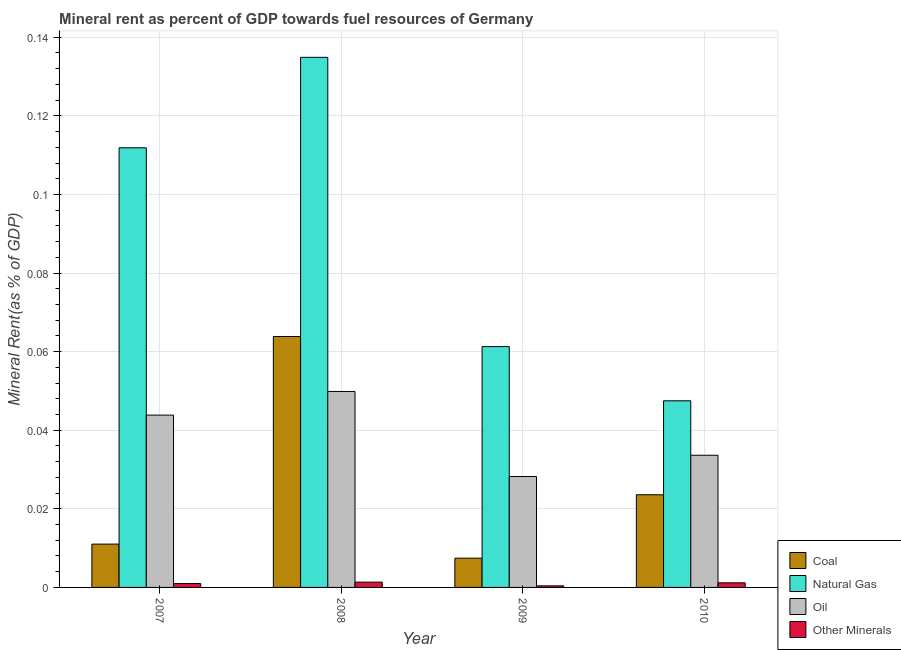How many different coloured bars are there?
Ensure brevity in your answer.  4. How many groups of bars are there?
Your answer should be compact. 4. Are the number of bars on each tick of the X-axis equal?
Make the answer very short. Yes. In how many cases, is the number of bars for a given year not equal to the number of legend labels?
Provide a succinct answer. 0. What is the natural gas rent in 2009?
Offer a very short reply. 0.06. Across all years, what is the maximum coal rent?
Your answer should be compact. 0.06. Across all years, what is the minimum  rent of other minerals?
Offer a terse response. 0. What is the total coal rent in the graph?
Provide a succinct answer. 0.11. What is the difference between the natural gas rent in 2008 and that in 2010?
Offer a very short reply. 0.09. What is the difference between the coal rent in 2010 and the  rent of other minerals in 2007?
Ensure brevity in your answer.  0.01. What is the average natural gas rent per year?
Provide a succinct answer. 0.09. In the year 2010, what is the difference between the  rent of other minerals and coal rent?
Your answer should be very brief. 0. In how many years, is the natural gas rent greater than 0.132 %?
Provide a succinct answer. 1. What is the ratio of the  rent of other minerals in 2008 to that in 2009?
Give a very brief answer. 3.35. Is the natural gas rent in 2007 less than that in 2010?
Provide a succinct answer. No. What is the difference between the highest and the second highest natural gas rent?
Offer a terse response. 0.02. What is the difference between the highest and the lowest oil rent?
Your answer should be compact. 0.02. What does the 3rd bar from the left in 2009 represents?
Give a very brief answer. Oil. What does the 4th bar from the right in 2009 represents?
Provide a short and direct response. Coal. Are the values on the major ticks of Y-axis written in scientific E-notation?
Ensure brevity in your answer.  No. Does the graph contain any zero values?
Give a very brief answer. No. Where does the legend appear in the graph?
Provide a succinct answer. Bottom right. What is the title of the graph?
Your answer should be very brief. Mineral rent as percent of GDP towards fuel resources of Germany. Does "Manufacturing" appear as one of the legend labels in the graph?
Give a very brief answer. No. What is the label or title of the Y-axis?
Keep it short and to the point. Mineral Rent(as % of GDP). What is the Mineral Rent(as % of GDP) in Coal in 2007?
Provide a short and direct response. 0.01. What is the Mineral Rent(as % of GDP) of Natural Gas in 2007?
Provide a short and direct response. 0.11. What is the Mineral Rent(as % of GDP) of Oil in 2007?
Make the answer very short. 0.04. What is the Mineral Rent(as % of GDP) of Other Minerals in 2007?
Make the answer very short. 0. What is the Mineral Rent(as % of GDP) of Coal in 2008?
Offer a very short reply. 0.06. What is the Mineral Rent(as % of GDP) in Natural Gas in 2008?
Provide a succinct answer. 0.13. What is the Mineral Rent(as % of GDP) in Oil in 2008?
Provide a succinct answer. 0.05. What is the Mineral Rent(as % of GDP) of Other Minerals in 2008?
Make the answer very short. 0. What is the Mineral Rent(as % of GDP) of Coal in 2009?
Ensure brevity in your answer.  0.01. What is the Mineral Rent(as % of GDP) in Natural Gas in 2009?
Give a very brief answer. 0.06. What is the Mineral Rent(as % of GDP) of Oil in 2009?
Provide a short and direct response. 0.03. What is the Mineral Rent(as % of GDP) in Other Minerals in 2009?
Your answer should be very brief. 0. What is the Mineral Rent(as % of GDP) in Coal in 2010?
Your response must be concise. 0.02. What is the Mineral Rent(as % of GDP) of Natural Gas in 2010?
Give a very brief answer. 0.05. What is the Mineral Rent(as % of GDP) of Oil in 2010?
Your answer should be compact. 0.03. What is the Mineral Rent(as % of GDP) of Other Minerals in 2010?
Your answer should be compact. 0. Across all years, what is the maximum Mineral Rent(as % of GDP) of Coal?
Offer a very short reply. 0.06. Across all years, what is the maximum Mineral Rent(as % of GDP) in Natural Gas?
Ensure brevity in your answer.  0.13. Across all years, what is the maximum Mineral Rent(as % of GDP) in Oil?
Give a very brief answer. 0.05. Across all years, what is the maximum Mineral Rent(as % of GDP) of Other Minerals?
Offer a terse response. 0. Across all years, what is the minimum Mineral Rent(as % of GDP) in Coal?
Offer a very short reply. 0.01. Across all years, what is the minimum Mineral Rent(as % of GDP) in Natural Gas?
Provide a succinct answer. 0.05. Across all years, what is the minimum Mineral Rent(as % of GDP) of Oil?
Give a very brief answer. 0.03. Across all years, what is the minimum Mineral Rent(as % of GDP) in Other Minerals?
Give a very brief answer. 0. What is the total Mineral Rent(as % of GDP) in Coal in the graph?
Give a very brief answer. 0.11. What is the total Mineral Rent(as % of GDP) of Natural Gas in the graph?
Keep it short and to the point. 0.36. What is the total Mineral Rent(as % of GDP) of Oil in the graph?
Your answer should be compact. 0.16. What is the total Mineral Rent(as % of GDP) in Other Minerals in the graph?
Your response must be concise. 0. What is the difference between the Mineral Rent(as % of GDP) in Coal in 2007 and that in 2008?
Keep it short and to the point. -0.05. What is the difference between the Mineral Rent(as % of GDP) in Natural Gas in 2007 and that in 2008?
Ensure brevity in your answer.  -0.02. What is the difference between the Mineral Rent(as % of GDP) in Oil in 2007 and that in 2008?
Provide a short and direct response. -0.01. What is the difference between the Mineral Rent(as % of GDP) of Other Minerals in 2007 and that in 2008?
Your response must be concise. -0. What is the difference between the Mineral Rent(as % of GDP) of Coal in 2007 and that in 2009?
Keep it short and to the point. 0. What is the difference between the Mineral Rent(as % of GDP) of Natural Gas in 2007 and that in 2009?
Offer a very short reply. 0.05. What is the difference between the Mineral Rent(as % of GDP) in Oil in 2007 and that in 2009?
Your response must be concise. 0.02. What is the difference between the Mineral Rent(as % of GDP) of Other Minerals in 2007 and that in 2009?
Provide a succinct answer. 0. What is the difference between the Mineral Rent(as % of GDP) of Coal in 2007 and that in 2010?
Your answer should be very brief. -0.01. What is the difference between the Mineral Rent(as % of GDP) of Natural Gas in 2007 and that in 2010?
Ensure brevity in your answer.  0.06. What is the difference between the Mineral Rent(as % of GDP) in Oil in 2007 and that in 2010?
Provide a short and direct response. 0.01. What is the difference between the Mineral Rent(as % of GDP) in Other Minerals in 2007 and that in 2010?
Your response must be concise. -0. What is the difference between the Mineral Rent(as % of GDP) in Coal in 2008 and that in 2009?
Provide a succinct answer. 0.06. What is the difference between the Mineral Rent(as % of GDP) in Natural Gas in 2008 and that in 2009?
Provide a succinct answer. 0.07. What is the difference between the Mineral Rent(as % of GDP) in Oil in 2008 and that in 2009?
Provide a succinct answer. 0.02. What is the difference between the Mineral Rent(as % of GDP) in Other Minerals in 2008 and that in 2009?
Ensure brevity in your answer.  0. What is the difference between the Mineral Rent(as % of GDP) of Coal in 2008 and that in 2010?
Provide a short and direct response. 0.04. What is the difference between the Mineral Rent(as % of GDP) in Natural Gas in 2008 and that in 2010?
Provide a succinct answer. 0.09. What is the difference between the Mineral Rent(as % of GDP) in Oil in 2008 and that in 2010?
Offer a terse response. 0.02. What is the difference between the Mineral Rent(as % of GDP) in Other Minerals in 2008 and that in 2010?
Provide a short and direct response. 0. What is the difference between the Mineral Rent(as % of GDP) in Coal in 2009 and that in 2010?
Make the answer very short. -0.02. What is the difference between the Mineral Rent(as % of GDP) in Natural Gas in 2009 and that in 2010?
Your answer should be very brief. 0.01. What is the difference between the Mineral Rent(as % of GDP) in Oil in 2009 and that in 2010?
Make the answer very short. -0.01. What is the difference between the Mineral Rent(as % of GDP) in Other Minerals in 2009 and that in 2010?
Give a very brief answer. -0. What is the difference between the Mineral Rent(as % of GDP) in Coal in 2007 and the Mineral Rent(as % of GDP) in Natural Gas in 2008?
Your response must be concise. -0.12. What is the difference between the Mineral Rent(as % of GDP) of Coal in 2007 and the Mineral Rent(as % of GDP) of Oil in 2008?
Offer a terse response. -0.04. What is the difference between the Mineral Rent(as % of GDP) of Coal in 2007 and the Mineral Rent(as % of GDP) of Other Minerals in 2008?
Your answer should be compact. 0.01. What is the difference between the Mineral Rent(as % of GDP) of Natural Gas in 2007 and the Mineral Rent(as % of GDP) of Oil in 2008?
Offer a very short reply. 0.06. What is the difference between the Mineral Rent(as % of GDP) in Natural Gas in 2007 and the Mineral Rent(as % of GDP) in Other Minerals in 2008?
Your answer should be very brief. 0.11. What is the difference between the Mineral Rent(as % of GDP) of Oil in 2007 and the Mineral Rent(as % of GDP) of Other Minerals in 2008?
Offer a very short reply. 0.04. What is the difference between the Mineral Rent(as % of GDP) of Coal in 2007 and the Mineral Rent(as % of GDP) of Natural Gas in 2009?
Provide a succinct answer. -0.05. What is the difference between the Mineral Rent(as % of GDP) of Coal in 2007 and the Mineral Rent(as % of GDP) of Oil in 2009?
Keep it short and to the point. -0.02. What is the difference between the Mineral Rent(as % of GDP) in Coal in 2007 and the Mineral Rent(as % of GDP) in Other Minerals in 2009?
Ensure brevity in your answer.  0.01. What is the difference between the Mineral Rent(as % of GDP) in Natural Gas in 2007 and the Mineral Rent(as % of GDP) in Oil in 2009?
Offer a terse response. 0.08. What is the difference between the Mineral Rent(as % of GDP) of Natural Gas in 2007 and the Mineral Rent(as % of GDP) of Other Minerals in 2009?
Offer a very short reply. 0.11. What is the difference between the Mineral Rent(as % of GDP) of Oil in 2007 and the Mineral Rent(as % of GDP) of Other Minerals in 2009?
Provide a succinct answer. 0.04. What is the difference between the Mineral Rent(as % of GDP) in Coal in 2007 and the Mineral Rent(as % of GDP) in Natural Gas in 2010?
Offer a very short reply. -0.04. What is the difference between the Mineral Rent(as % of GDP) of Coal in 2007 and the Mineral Rent(as % of GDP) of Oil in 2010?
Give a very brief answer. -0.02. What is the difference between the Mineral Rent(as % of GDP) of Coal in 2007 and the Mineral Rent(as % of GDP) of Other Minerals in 2010?
Ensure brevity in your answer.  0.01. What is the difference between the Mineral Rent(as % of GDP) in Natural Gas in 2007 and the Mineral Rent(as % of GDP) in Oil in 2010?
Give a very brief answer. 0.08. What is the difference between the Mineral Rent(as % of GDP) of Natural Gas in 2007 and the Mineral Rent(as % of GDP) of Other Minerals in 2010?
Ensure brevity in your answer.  0.11. What is the difference between the Mineral Rent(as % of GDP) in Oil in 2007 and the Mineral Rent(as % of GDP) in Other Minerals in 2010?
Provide a succinct answer. 0.04. What is the difference between the Mineral Rent(as % of GDP) of Coal in 2008 and the Mineral Rent(as % of GDP) of Natural Gas in 2009?
Provide a succinct answer. 0. What is the difference between the Mineral Rent(as % of GDP) in Coal in 2008 and the Mineral Rent(as % of GDP) in Oil in 2009?
Offer a terse response. 0.04. What is the difference between the Mineral Rent(as % of GDP) of Coal in 2008 and the Mineral Rent(as % of GDP) of Other Minerals in 2009?
Provide a succinct answer. 0.06. What is the difference between the Mineral Rent(as % of GDP) in Natural Gas in 2008 and the Mineral Rent(as % of GDP) in Oil in 2009?
Provide a succinct answer. 0.11. What is the difference between the Mineral Rent(as % of GDP) of Natural Gas in 2008 and the Mineral Rent(as % of GDP) of Other Minerals in 2009?
Your response must be concise. 0.13. What is the difference between the Mineral Rent(as % of GDP) in Oil in 2008 and the Mineral Rent(as % of GDP) in Other Minerals in 2009?
Your response must be concise. 0.05. What is the difference between the Mineral Rent(as % of GDP) of Coal in 2008 and the Mineral Rent(as % of GDP) of Natural Gas in 2010?
Ensure brevity in your answer.  0.02. What is the difference between the Mineral Rent(as % of GDP) of Coal in 2008 and the Mineral Rent(as % of GDP) of Oil in 2010?
Provide a short and direct response. 0.03. What is the difference between the Mineral Rent(as % of GDP) of Coal in 2008 and the Mineral Rent(as % of GDP) of Other Minerals in 2010?
Make the answer very short. 0.06. What is the difference between the Mineral Rent(as % of GDP) of Natural Gas in 2008 and the Mineral Rent(as % of GDP) of Oil in 2010?
Make the answer very short. 0.1. What is the difference between the Mineral Rent(as % of GDP) in Natural Gas in 2008 and the Mineral Rent(as % of GDP) in Other Minerals in 2010?
Offer a terse response. 0.13. What is the difference between the Mineral Rent(as % of GDP) in Oil in 2008 and the Mineral Rent(as % of GDP) in Other Minerals in 2010?
Provide a succinct answer. 0.05. What is the difference between the Mineral Rent(as % of GDP) in Coal in 2009 and the Mineral Rent(as % of GDP) in Natural Gas in 2010?
Your response must be concise. -0.04. What is the difference between the Mineral Rent(as % of GDP) of Coal in 2009 and the Mineral Rent(as % of GDP) of Oil in 2010?
Ensure brevity in your answer.  -0.03. What is the difference between the Mineral Rent(as % of GDP) of Coal in 2009 and the Mineral Rent(as % of GDP) of Other Minerals in 2010?
Keep it short and to the point. 0.01. What is the difference between the Mineral Rent(as % of GDP) in Natural Gas in 2009 and the Mineral Rent(as % of GDP) in Oil in 2010?
Your response must be concise. 0.03. What is the difference between the Mineral Rent(as % of GDP) in Natural Gas in 2009 and the Mineral Rent(as % of GDP) in Other Minerals in 2010?
Offer a terse response. 0.06. What is the difference between the Mineral Rent(as % of GDP) in Oil in 2009 and the Mineral Rent(as % of GDP) in Other Minerals in 2010?
Give a very brief answer. 0.03. What is the average Mineral Rent(as % of GDP) in Coal per year?
Keep it short and to the point. 0.03. What is the average Mineral Rent(as % of GDP) of Natural Gas per year?
Offer a terse response. 0.09. What is the average Mineral Rent(as % of GDP) of Oil per year?
Offer a terse response. 0.04. What is the average Mineral Rent(as % of GDP) of Other Minerals per year?
Keep it short and to the point. 0. In the year 2007, what is the difference between the Mineral Rent(as % of GDP) in Coal and Mineral Rent(as % of GDP) in Natural Gas?
Your response must be concise. -0.1. In the year 2007, what is the difference between the Mineral Rent(as % of GDP) of Coal and Mineral Rent(as % of GDP) of Oil?
Offer a very short reply. -0.03. In the year 2007, what is the difference between the Mineral Rent(as % of GDP) in Natural Gas and Mineral Rent(as % of GDP) in Oil?
Offer a terse response. 0.07. In the year 2007, what is the difference between the Mineral Rent(as % of GDP) in Natural Gas and Mineral Rent(as % of GDP) in Other Minerals?
Make the answer very short. 0.11. In the year 2007, what is the difference between the Mineral Rent(as % of GDP) of Oil and Mineral Rent(as % of GDP) of Other Minerals?
Offer a very short reply. 0.04. In the year 2008, what is the difference between the Mineral Rent(as % of GDP) in Coal and Mineral Rent(as % of GDP) in Natural Gas?
Provide a short and direct response. -0.07. In the year 2008, what is the difference between the Mineral Rent(as % of GDP) in Coal and Mineral Rent(as % of GDP) in Oil?
Your answer should be compact. 0.01. In the year 2008, what is the difference between the Mineral Rent(as % of GDP) in Coal and Mineral Rent(as % of GDP) in Other Minerals?
Ensure brevity in your answer.  0.06. In the year 2008, what is the difference between the Mineral Rent(as % of GDP) of Natural Gas and Mineral Rent(as % of GDP) of Oil?
Your answer should be very brief. 0.09. In the year 2008, what is the difference between the Mineral Rent(as % of GDP) in Natural Gas and Mineral Rent(as % of GDP) in Other Minerals?
Offer a very short reply. 0.13. In the year 2008, what is the difference between the Mineral Rent(as % of GDP) of Oil and Mineral Rent(as % of GDP) of Other Minerals?
Ensure brevity in your answer.  0.05. In the year 2009, what is the difference between the Mineral Rent(as % of GDP) of Coal and Mineral Rent(as % of GDP) of Natural Gas?
Give a very brief answer. -0.05. In the year 2009, what is the difference between the Mineral Rent(as % of GDP) of Coal and Mineral Rent(as % of GDP) of Oil?
Your response must be concise. -0.02. In the year 2009, what is the difference between the Mineral Rent(as % of GDP) in Coal and Mineral Rent(as % of GDP) in Other Minerals?
Make the answer very short. 0.01. In the year 2009, what is the difference between the Mineral Rent(as % of GDP) in Natural Gas and Mineral Rent(as % of GDP) in Oil?
Offer a very short reply. 0.03. In the year 2009, what is the difference between the Mineral Rent(as % of GDP) in Natural Gas and Mineral Rent(as % of GDP) in Other Minerals?
Your response must be concise. 0.06. In the year 2009, what is the difference between the Mineral Rent(as % of GDP) of Oil and Mineral Rent(as % of GDP) of Other Minerals?
Make the answer very short. 0.03. In the year 2010, what is the difference between the Mineral Rent(as % of GDP) in Coal and Mineral Rent(as % of GDP) in Natural Gas?
Give a very brief answer. -0.02. In the year 2010, what is the difference between the Mineral Rent(as % of GDP) of Coal and Mineral Rent(as % of GDP) of Oil?
Give a very brief answer. -0.01. In the year 2010, what is the difference between the Mineral Rent(as % of GDP) of Coal and Mineral Rent(as % of GDP) of Other Minerals?
Your answer should be compact. 0.02. In the year 2010, what is the difference between the Mineral Rent(as % of GDP) of Natural Gas and Mineral Rent(as % of GDP) of Oil?
Ensure brevity in your answer.  0.01. In the year 2010, what is the difference between the Mineral Rent(as % of GDP) of Natural Gas and Mineral Rent(as % of GDP) of Other Minerals?
Offer a terse response. 0.05. In the year 2010, what is the difference between the Mineral Rent(as % of GDP) of Oil and Mineral Rent(as % of GDP) of Other Minerals?
Offer a very short reply. 0.03. What is the ratio of the Mineral Rent(as % of GDP) in Coal in 2007 to that in 2008?
Your answer should be compact. 0.17. What is the ratio of the Mineral Rent(as % of GDP) of Natural Gas in 2007 to that in 2008?
Provide a short and direct response. 0.83. What is the ratio of the Mineral Rent(as % of GDP) in Oil in 2007 to that in 2008?
Offer a very short reply. 0.88. What is the ratio of the Mineral Rent(as % of GDP) in Other Minerals in 2007 to that in 2008?
Make the answer very short. 0.74. What is the ratio of the Mineral Rent(as % of GDP) in Coal in 2007 to that in 2009?
Provide a short and direct response. 1.48. What is the ratio of the Mineral Rent(as % of GDP) in Natural Gas in 2007 to that in 2009?
Give a very brief answer. 1.83. What is the ratio of the Mineral Rent(as % of GDP) in Oil in 2007 to that in 2009?
Keep it short and to the point. 1.55. What is the ratio of the Mineral Rent(as % of GDP) in Other Minerals in 2007 to that in 2009?
Your response must be concise. 2.48. What is the ratio of the Mineral Rent(as % of GDP) of Coal in 2007 to that in 2010?
Your response must be concise. 0.47. What is the ratio of the Mineral Rent(as % of GDP) of Natural Gas in 2007 to that in 2010?
Provide a short and direct response. 2.36. What is the ratio of the Mineral Rent(as % of GDP) in Oil in 2007 to that in 2010?
Your answer should be compact. 1.3. What is the ratio of the Mineral Rent(as % of GDP) of Other Minerals in 2007 to that in 2010?
Make the answer very short. 0.85. What is the ratio of the Mineral Rent(as % of GDP) in Coal in 2008 to that in 2009?
Offer a terse response. 8.58. What is the ratio of the Mineral Rent(as % of GDP) of Natural Gas in 2008 to that in 2009?
Your answer should be compact. 2.2. What is the ratio of the Mineral Rent(as % of GDP) of Oil in 2008 to that in 2009?
Give a very brief answer. 1.77. What is the ratio of the Mineral Rent(as % of GDP) of Other Minerals in 2008 to that in 2009?
Keep it short and to the point. 3.35. What is the ratio of the Mineral Rent(as % of GDP) in Coal in 2008 to that in 2010?
Keep it short and to the point. 2.71. What is the ratio of the Mineral Rent(as % of GDP) of Natural Gas in 2008 to that in 2010?
Offer a terse response. 2.84. What is the ratio of the Mineral Rent(as % of GDP) in Oil in 2008 to that in 2010?
Provide a short and direct response. 1.48. What is the ratio of the Mineral Rent(as % of GDP) in Other Minerals in 2008 to that in 2010?
Offer a very short reply. 1.15. What is the ratio of the Mineral Rent(as % of GDP) in Coal in 2009 to that in 2010?
Make the answer very short. 0.32. What is the ratio of the Mineral Rent(as % of GDP) of Natural Gas in 2009 to that in 2010?
Your response must be concise. 1.29. What is the ratio of the Mineral Rent(as % of GDP) in Oil in 2009 to that in 2010?
Provide a succinct answer. 0.84. What is the ratio of the Mineral Rent(as % of GDP) of Other Minerals in 2009 to that in 2010?
Make the answer very short. 0.34. What is the difference between the highest and the second highest Mineral Rent(as % of GDP) in Coal?
Your answer should be compact. 0.04. What is the difference between the highest and the second highest Mineral Rent(as % of GDP) in Natural Gas?
Keep it short and to the point. 0.02. What is the difference between the highest and the second highest Mineral Rent(as % of GDP) in Oil?
Keep it short and to the point. 0.01. What is the difference between the highest and the second highest Mineral Rent(as % of GDP) of Other Minerals?
Keep it short and to the point. 0. What is the difference between the highest and the lowest Mineral Rent(as % of GDP) of Coal?
Your response must be concise. 0.06. What is the difference between the highest and the lowest Mineral Rent(as % of GDP) of Natural Gas?
Provide a succinct answer. 0.09. What is the difference between the highest and the lowest Mineral Rent(as % of GDP) of Oil?
Offer a terse response. 0.02. What is the difference between the highest and the lowest Mineral Rent(as % of GDP) of Other Minerals?
Your answer should be compact. 0. 